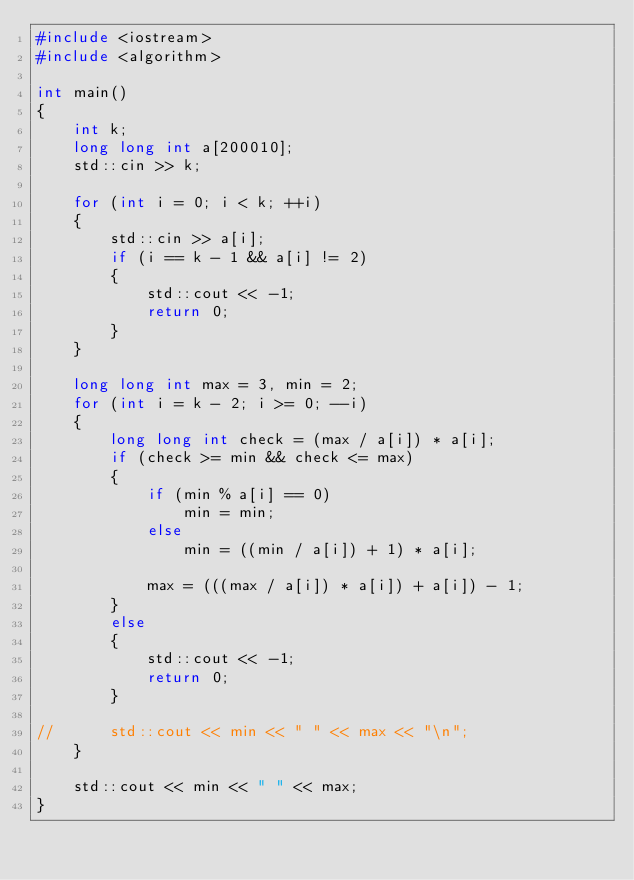Convert code to text. <code><loc_0><loc_0><loc_500><loc_500><_C++_>#include <iostream>
#include <algorithm>

int main()
{
	int k;
	long long int a[200010];
	std::cin >> k;
	
	for (int i = 0; i < k; ++i)
	{
		std::cin >> a[i];
		if (i == k - 1 && a[i] != 2)
		{
			std::cout << -1;
			return 0;
		}
	}
	
	long long int max = 3, min = 2;
	for (int i = k - 2; i >= 0; --i)
	{
		long long int check = (max / a[i]) * a[i];
		if (check >= min && check <= max)
		{
			if (min % a[i] == 0)
				min = min;
			else
				min = ((min / a[i]) + 1) * a[i];
			
			max = (((max / a[i]) * a[i]) + a[i]) - 1;
		}
		else
		{
			std::cout << -1;
			return 0;
		}
		
//		std::cout << min << " " << max << "\n";
	}
	
	std::cout << min << " " << max;
}</code> 